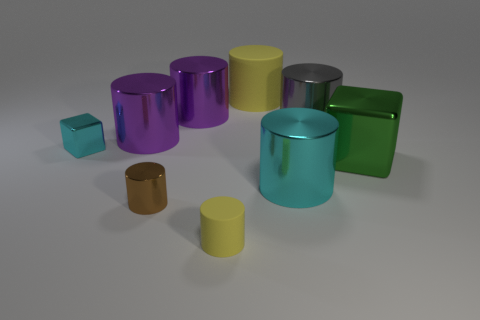Subtract 3 cylinders. How many cylinders are left? 4 Subtract all purple cylinders. How many cylinders are left? 5 Subtract all purple shiny cylinders. How many cylinders are left? 5 Subtract all brown cylinders. Subtract all gray cubes. How many cylinders are left? 6 Add 1 large cylinders. How many objects exist? 10 Subtract all cubes. How many objects are left? 7 Add 1 tiny brown things. How many tiny brown things are left? 2 Add 5 brown metallic objects. How many brown metallic objects exist? 6 Subtract 0 red balls. How many objects are left? 9 Subtract all purple cylinders. Subtract all rubber objects. How many objects are left? 5 